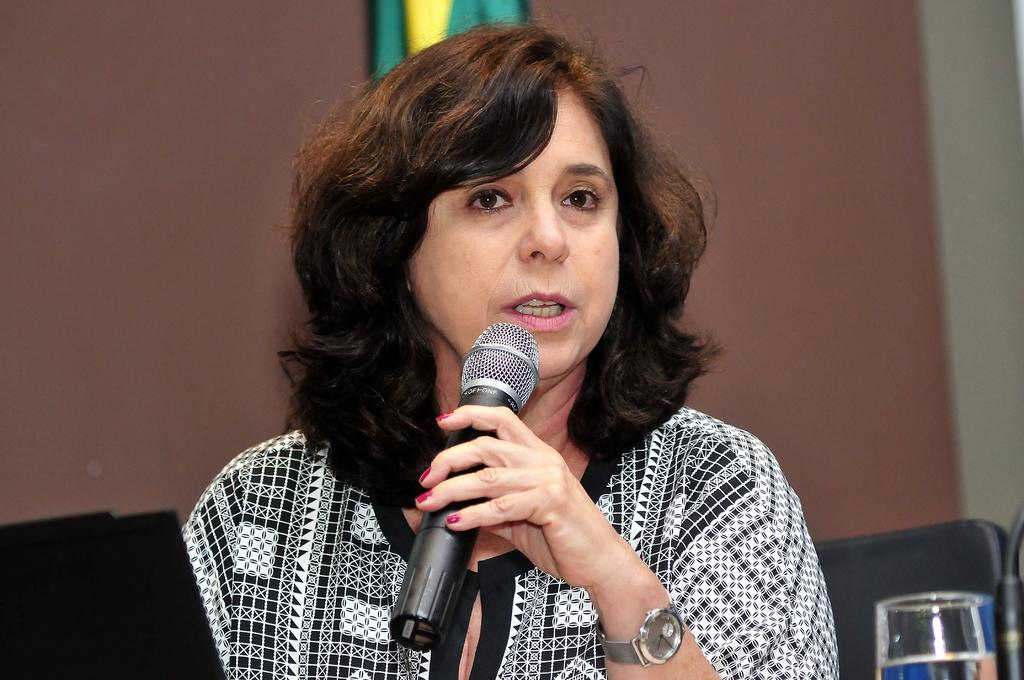Who is the main subject in the image? There is a woman in the image. What is the woman doing in the image? The woman is talking in the image. What object is the woman holding in her hand? The woman is holding a microphone in her hand. What accessory is the woman wearing on her wrist? The woman is wearing a watch. What can be seen in the background of the image? There is a wall in the background of the image. What type of cakes can be seen on the playground in the image? There is no mention of cakes or a playground in the image; it features a woman talking while holding a microphone. How many mittens are visible on the woman's hands in the image? The woman is not wearing any mittens in the image; she is wearing a watch on her wrist. 